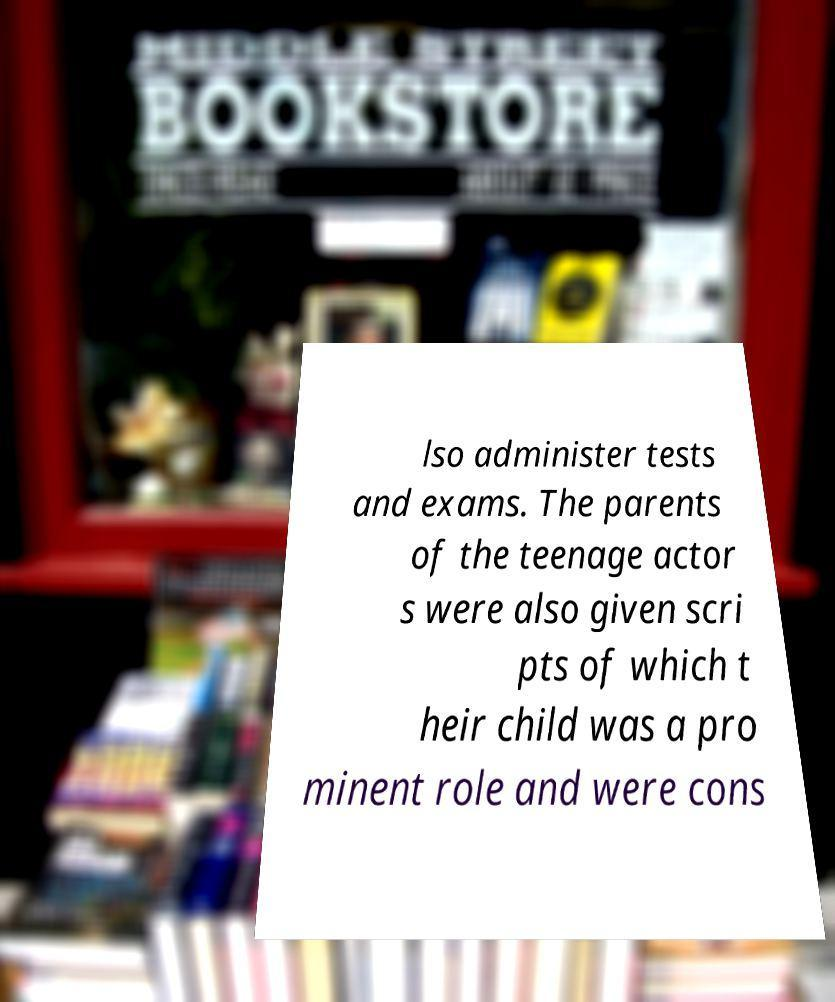Can you accurately transcribe the text from the provided image for me? lso administer tests and exams. The parents of the teenage actor s were also given scri pts of which t heir child was a pro minent role and were cons 